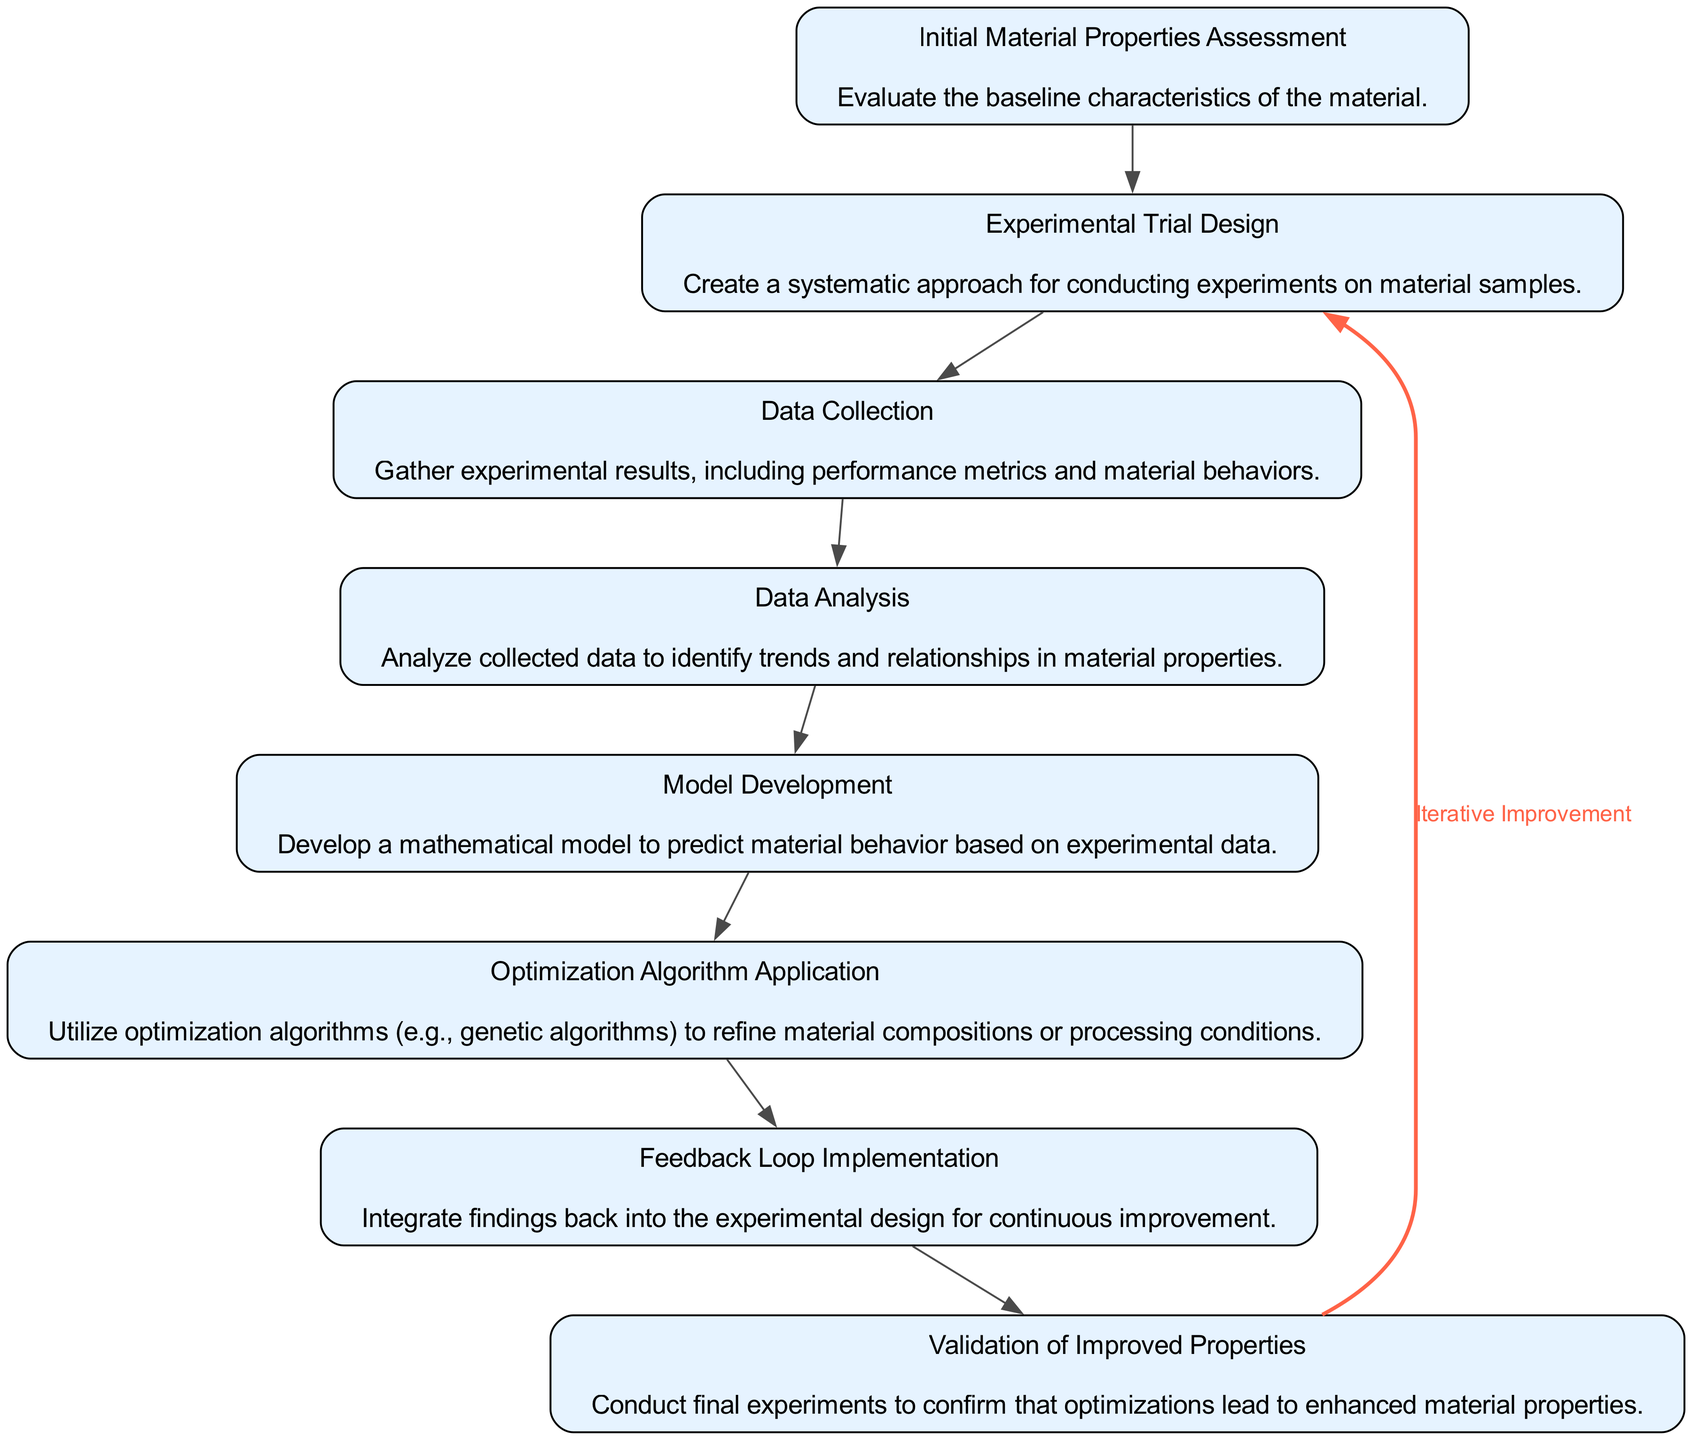What is the first step in the process? The first step according to the diagram is "Initial Material Properties Assessment," which evaluates the baseline characteristics of the material.
Answer: Initial Material Properties Assessment How many main steps are in the diagram? There are a total of 8 main steps (or nodes) represented in the diagram, detailing the iterative improvement process.
Answer: 8 Which step follows "Data Analysis"? The step that directly follows "Data Analysis" is "Model Development," indicating that after analyzing the data, a mathematical model is developed.
Answer: Model Development What kind of loop is implemented in the diagram? The diagram features a feedback loop for "Iterative Improvement" that connects the validation of improved properties back to the initial material properties assessment.
Answer: Iterative Improvement Which node is connected back to the first step? The node "Validation of Improved Properties" is connected back to the node "Initial Material Properties Assessment," indicating the cyclical nature of improvement.
Answer: Validation of Improved Properties Which step utilizes optimization algorithms? The step titled "Optimization Algorithm Application" specifically mentions the use of optimization algorithms to enhance material properties.
Answer: Optimization Algorithm Application What is the description of the "Feedback Loop Implementation" step? "Feedback Loop Implementation" integrates findings back into the experimental design for continuous improvement as stated in the diagram.
Answer: Integrate findings back Which step is at the end of the sequence before the feedback loop? The last step before the feedback loop is "Validation of Improved Properties," confirming that the optimizations achieve improved properties.
Answer: Validation of Improved Properties How does "Model Development" relate to the previous step? "Model Development" follows "Data Analysis," indicating that the analysis of collected data leads to the creation of a predictive mathematical model.
Answer: Data Analysis 